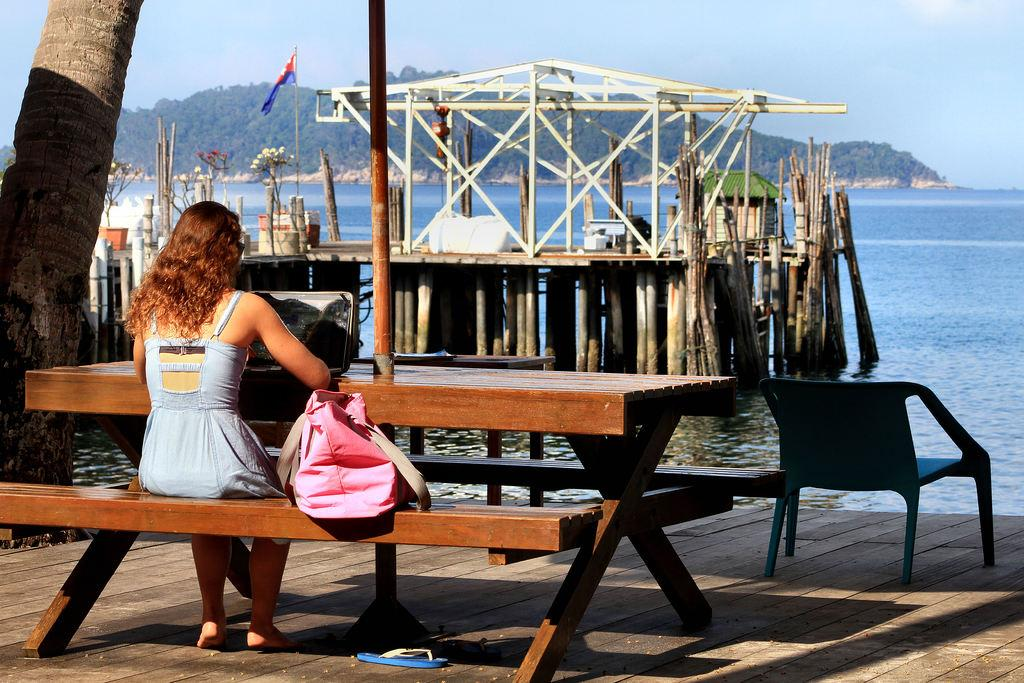What is the person in the image doing? The person is sitting at a table. What object is located next to the table? There is a bag next to the table. What can be seen in the background of the image? There is a sky, a flag, and a construction bridge visible in the background. What type of wound can be seen on the table in the image? There is no wound present on the table in the image. 